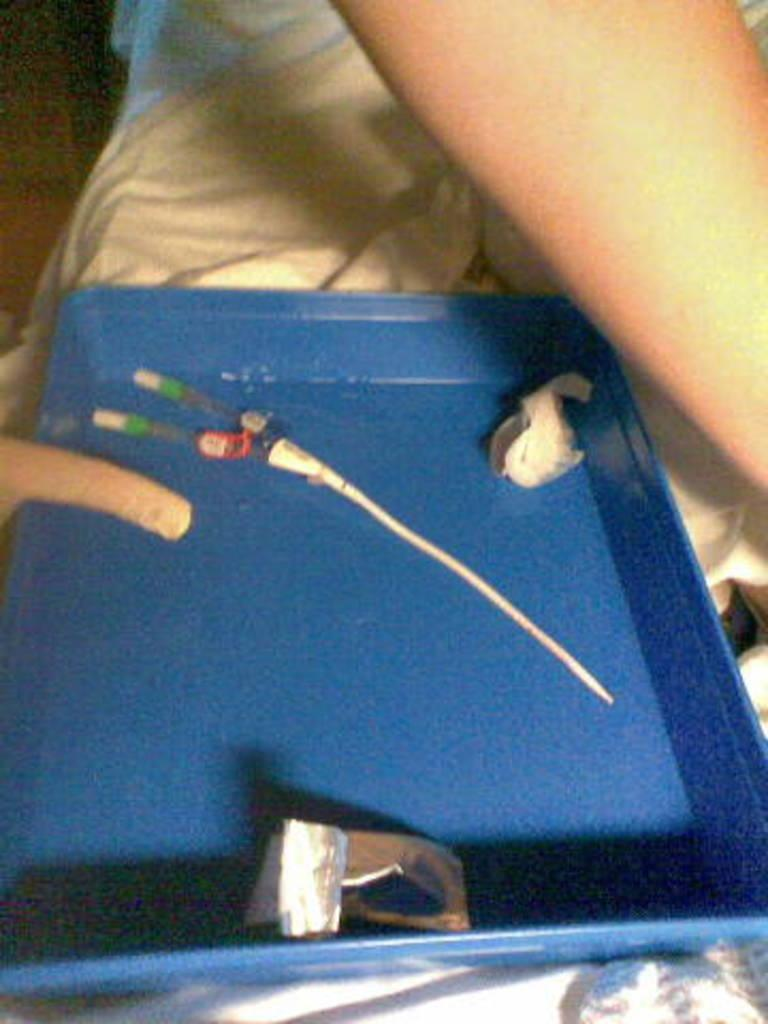What is present on the person's lap in the image? There is a tray in the image. What can be said about the tray's appearance? The tray is blue in color. Are there any objects on the tray? Yes, there are objects on the tray. Can you tell me how many buttons are on the person's wrist in the image? There is no mention of buttons or a wrist in the image; the focus is on the tray and its contents. 